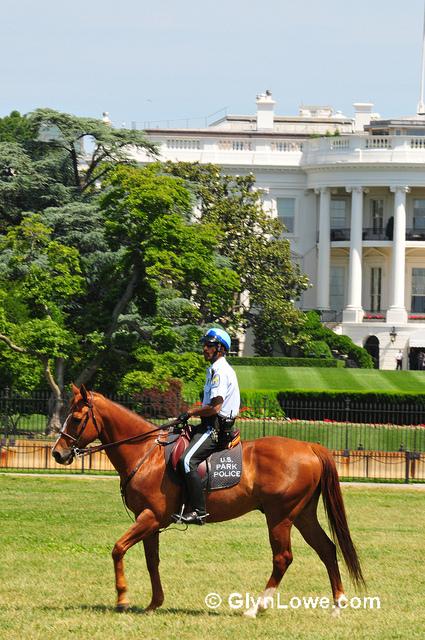Is the horse running?
Keep it brief. No. What country is this taken in?
Be succinct. Usa. Is he riding in the forest?
Answer briefly. No. 